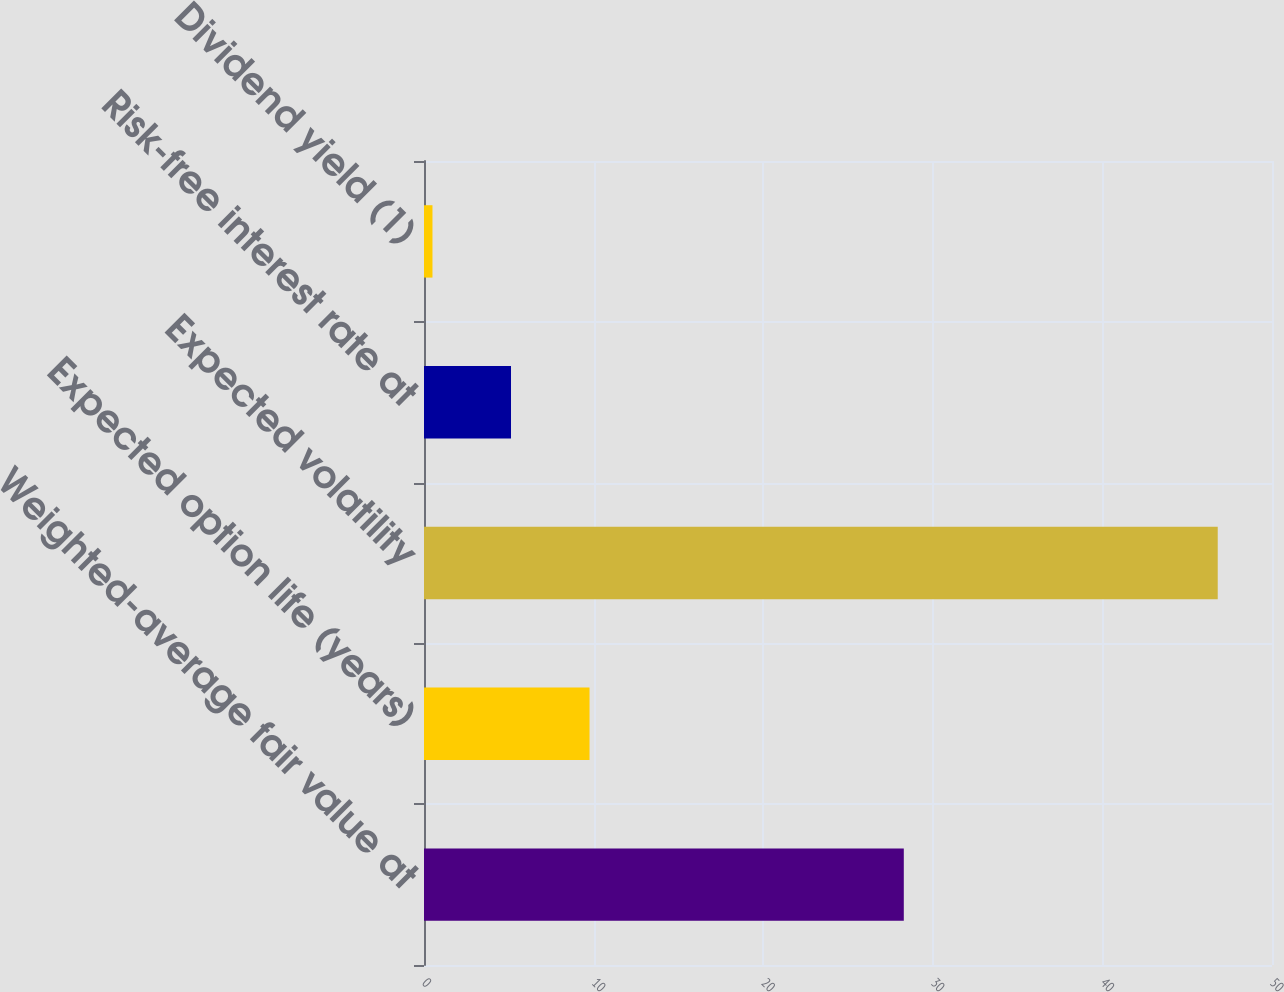Convert chart. <chart><loc_0><loc_0><loc_500><loc_500><bar_chart><fcel>Weighted-average fair value at<fcel>Expected option life (years)<fcel>Expected volatility<fcel>Risk-free interest rate at<fcel>Dividend yield (1)<nl><fcel>28.29<fcel>9.76<fcel>46.8<fcel>5.13<fcel>0.5<nl></chart> 